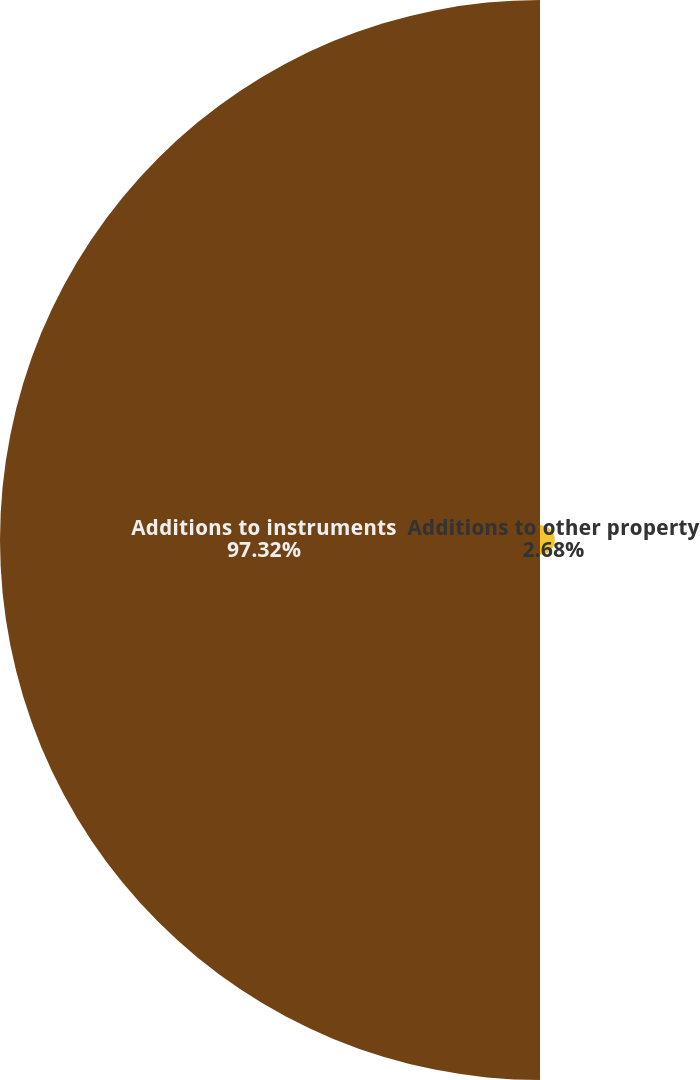<chart> <loc_0><loc_0><loc_500><loc_500><pie_chart><fcel>Additions to other property<fcel>Additions to instruments<nl><fcel>2.68%<fcel>97.32%<nl></chart> 